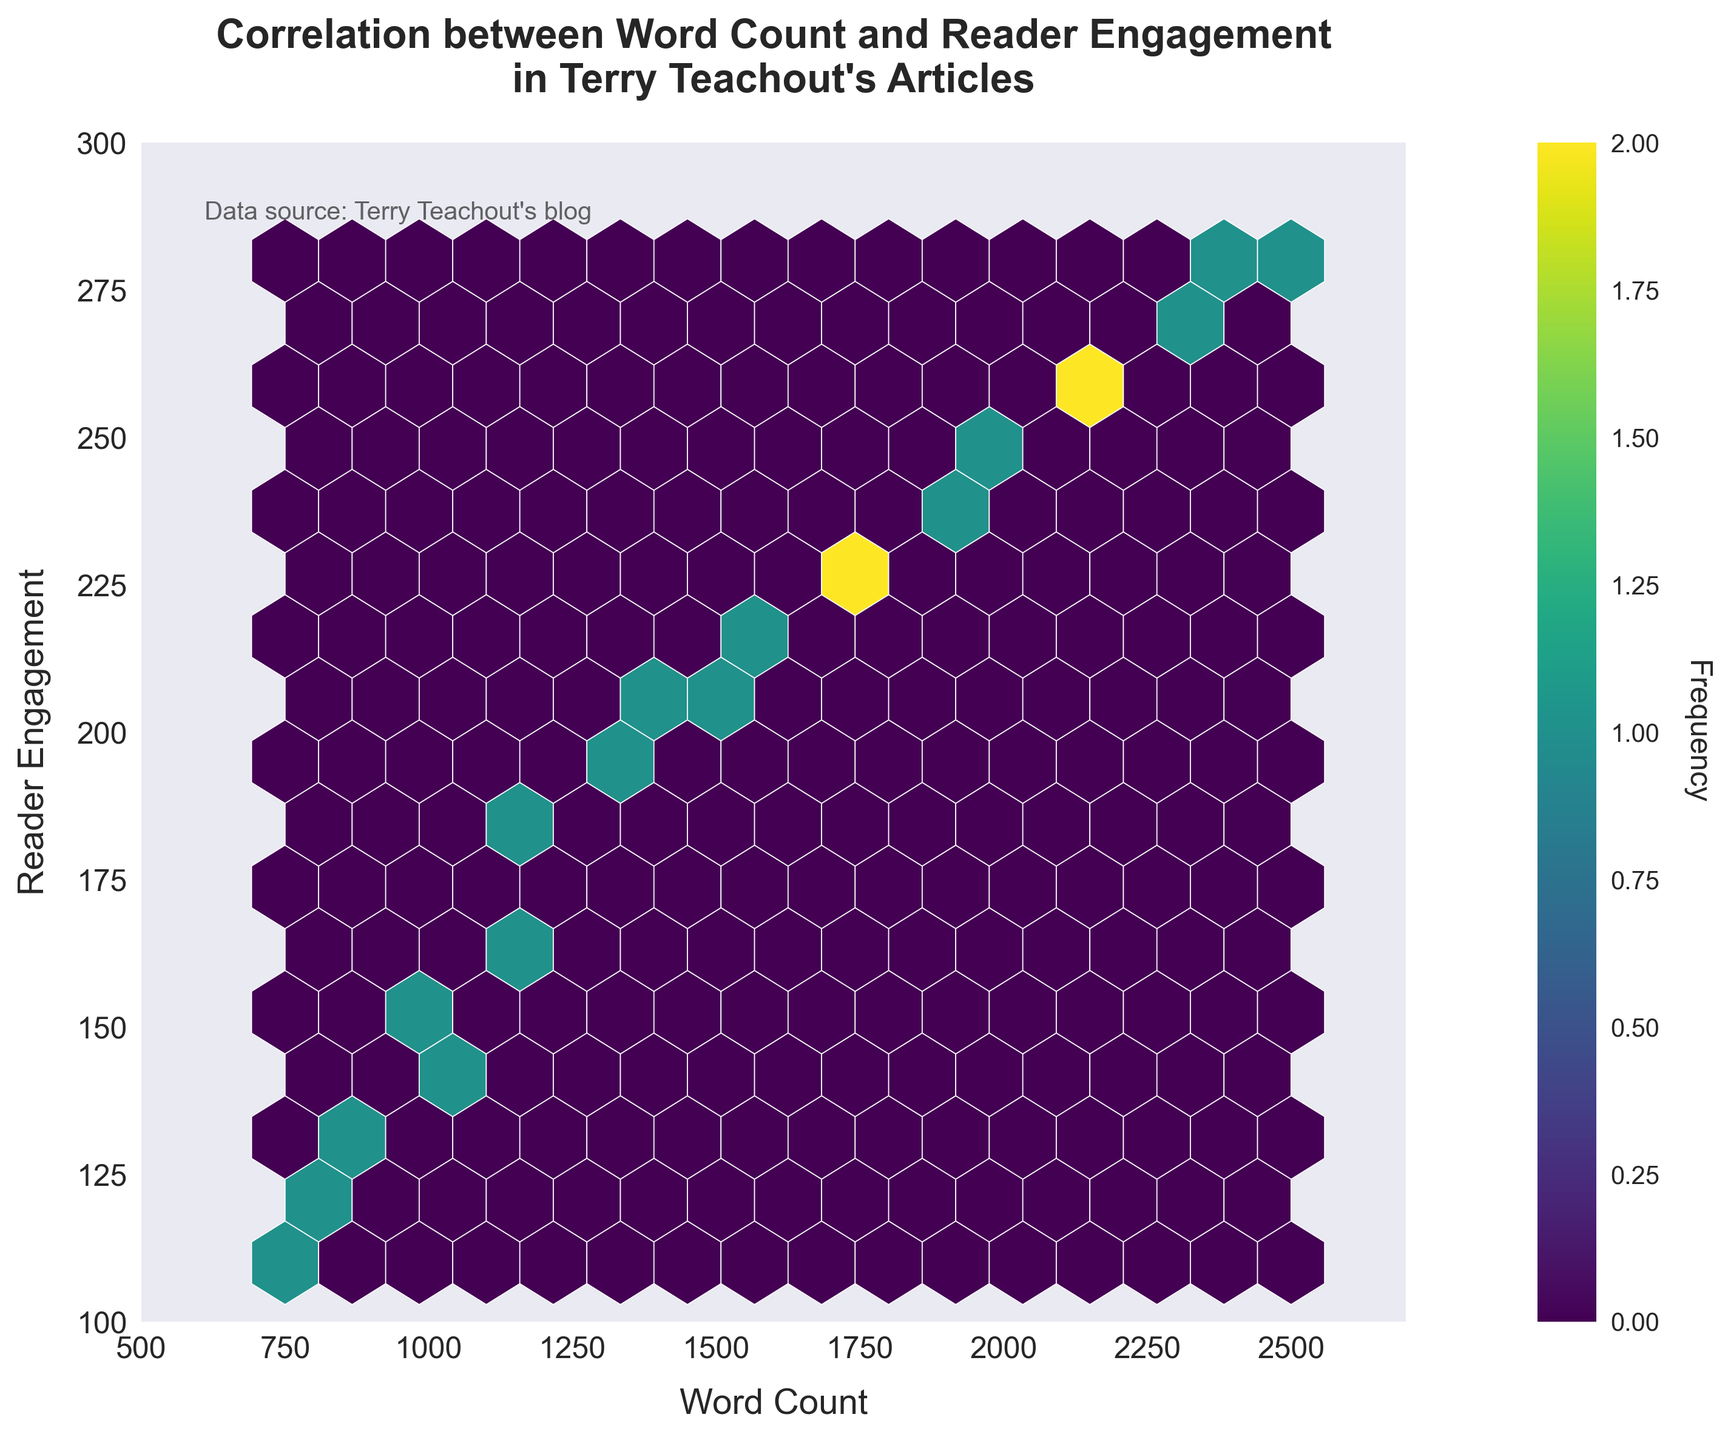What is the title of the figure? The title of the figure is placed at the top and is in bold font. By observing the plot, the title can be read as "Correlation between Word Count and Reader Engagement in Terry Teachout's Articles".
Answer: Correlation between Word Count and Reader Engagement in Terry Teachout's Articles What does the x-axis represent? The label of the x-axis can be found at the bottom of the plot; it states "Word Count".
Answer: Word Count What is the range of the y-axis? The labels on the y-axis start at 100 and go up to 300, based on the values placed along the axis.
Answer: 100 to 300 How many color bins are used in the hexbin plot? By examining the different shades of color present in the hexagons, we can count the distinct color bins used.
Answer: 15 Which word count has the highest reader engagement? By looking at the hexagon with the densest color (indicating highest reader engagement), we can trace it to the word count and reader engagement axes.
Answer: 2500 Where is the highest frequency of data points located? The area with the darkest hexagons indicates where the most data points are concentrated. By noting the axes' values at this location, we can identify the region.
Answer: Around (1500, 210) What does the color bar represent? The color bar is usually labeled and gives information about what the colors in the plot mean; in this case, it represents the "Frequency" of data points.
Answer: Frequency Which region has a higher reader engagement, 1700-word count or 1300-word count? Compare the colors of the hexagons at 1700-word count and 1300-word count. The darker hex receives a higher frequency and thus higher reader engagement.
Answer: 1700-word count What can be inferred about the relationship between word count and reader engagement? Analyze the trend shown by the hexagons and their colors; if darker hexagons (higher engagement) are associated with higher word counts, it indicates a positive trend.
Answer: Positive correlation How does the reader engagement change as the word count goes from 750 to 2400? By observing the hexagon color changes as the word count increases, we can see a progression in reader engagement values.
Answer: Engagement increases Is there a cluster of word counts and reader engagements that stands out? Identify the region with the most tightly packed high-frequency hexagons. This area's values indicate a significant cluster.
Answer: Around 1500-1800 word count and 200-220 reader engagement 